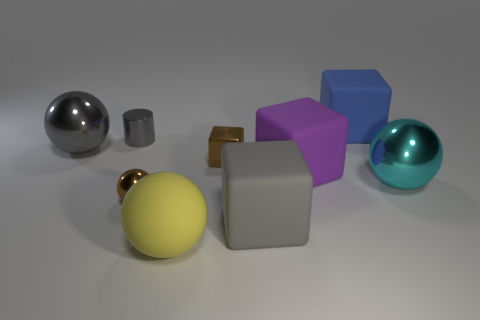Subtract all rubber balls. How many balls are left? 3 Subtract 1 blocks. How many blocks are left? 3 Subtract all purple cubes. How many cubes are left? 3 Add 9 tiny cyan cylinders. How many tiny cyan cylinders exist? 9 Subtract 0 cyan cylinders. How many objects are left? 9 Subtract all spheres. How many objects are left? 5 Subtract all yellow blocks. Subtract all brown cylinders. How many blocks are left? 4 Subtract all large yellow metal blocks. Subtract all purple rubber cubes. How many objects are left? 8 Add 5 small brown metal blocks. How many small brown metal blocks are left? 6 